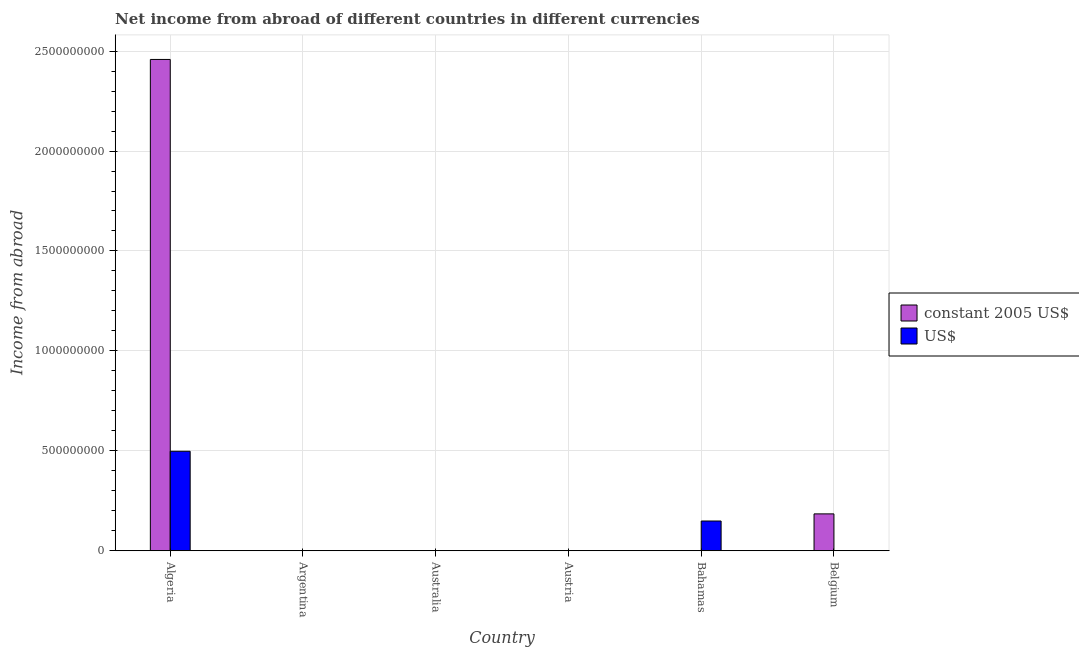How many different coloured bars are there?
Your answer should be compact. 2. Are the number of bars per tick equal to the number of legend labels?
Keep it short and to the point. No. How many bars are there on the 1st tick from the left?
Keep it short and to the point. 2. How many bars are there on the 1st tick from the right?
Give a very brief answer. 1. What is the label of the 3rd group of bars from the left?
Provide a short and direct response. Australia. What is the income from abroad in us$ in Austria?
Your answer should be very brief. 0. Across all countries, what is the maximum income from abroad in us$?
Your answer should be very brief. 4.98e+08. In which country was the income from abroad in us$ maximum?
Give a very brief answer. Algeria. What is the total income from abroad in constant 2005 us$ in the graph?
Your answer should be very brief. 2.64e+09. What is the difference between the income from abroad in constant 2005 us$ in Algeria and that in Belgium?
Ensure brevity in your answer.  2.27e+09. What is the difference between the income from abroad in constant 2005 us$ in Australia and the income from abroad in us$ in Argentina?
Your answer should be compact. 0. What is the average income from abroad in us$ per country?
Provide a succinct answer. 1.08e+08. What is the ratio of the income from abroad in constant 2005 us$ in Argentina to that in Belgium?
Your answer should be very brief. 1.8438339692605333e-11. What is the difference between the highest and the second highest income from abroad in constant 2005 us$?
Keep it short and to the point. 2.27e+09. What is the difference between the highest and the lowest income from abroad in constant 2005 us$?
Your response must be concise. 2.46e+09. In how many countries, is the income from abroad in us$ greater than the average income from abroad in us$ taken over all countries?
Offer a terse response. 2. How many bars are there?
Provide a succinct answer. 5. How many countries are there in the graph?
Provide a succinct answer. 6. Does the graph contain grids?
Your answer should be very brief. Yes. How many legend labels are there?
Your answer should be very brief. 2. What is the title of the graph?
Provide a short and direct response. Net income from abroad of different countries in different currencies. Does "Private funds" appear as one of the legend labels in the graph?
Make the answer very short. No. What is the label or title of the X-axis?
Give a very brief answer. Country. What is the label or title of the Y-axis?
Give a very brief answer. Income from abroad. What is the Income from abroad in constant 2005 US$ in Algeria?
Offer a terse response. 2.46e+09. What is the Income from abroad in US$ in Algeria?
Offer a very short reply. 4.98e+08. What is the Income from abroad in constant 2005 US$ in Argentina?
Offer a terse response. 0. What is the Income from abroad in US$ in Argentina?
Keep it short and to the point. 0. What is the Income from abroad in constant 2005 US$ in Australia?
Offer a very short reply. 0. What is the Income from abroad of constant 2005 US$ in Austria?
Keep it short and to the point. 0. What is the Income from abroad in US$ in Austria?
Your answer should be very brief. 0. What is the Income from abroad of US$ in Bahamas?
Keep it short and to the point. 1.49e+08. What is the Income from abroad of constant 2005 US$ in Belgium?
Ensure brevity in your answer.  1.85e+08. Across all countries, what is the maximum Income from abroad in constant 2005 US$?
Offer a terse response. 2.46e+09. Across all countries, what is the maximum Income from abroad of US$?
Give a very brief answer. 4.98e+08. Across all countries, what is the minimum Income from abroad of constant 2005 US$?
Give a very brief answer. 0. What is the total Income from abroad in constant 2005 US$ in the graph?
Your answer should be compact. 2.64e+09. What is the total Income from abroad in US$ in the graph?
Make the answer very short. 6.47e+08. What is the difference between the Income from abroad in constant 2005 US$ in Algeria and that in Argentina?
Ensure brevity in your answer.  2.46e+09. What is the difference between the Income from abroad in US$ in Algeria and that in Bahamas?
Provide a short and direct response. 3.49e+08. What is the difference between the Income from abroad of constant 2005 US$ in Algeria and that in Belgium?
Your answer should be very brief. 2.27e+09. What is the difference between the Income from abroad of constant 2005 US$ in Argentina and that in Belgium?
Your answer should be very brief. -1.85e+08. What is the difference between the Income from abroad of constant 2005 US$ in Algeria and the Income from abroad of US$ in Bahamas?
Provide a short and direct response. 2.31e+09. What is the difference between the Income from abroad of constant 2005 US$ in Argentina and the Income from abroad of US$ in Bahamas?
Provide a short and direct response. -1.49e+08. What is the average Income from abroad of constant 2005 US$ per country?
Offer a very short reply. 4.40e+08. What is the average Income from abroad in US$ per country?
Your response must be concise. 1.08e+08. What is the difference between the Income from abroad of constant 2005 US$ and Income from abroad of US$ in Algeria?
Provide a succinct answer. 1.96e+09. What is the ratio of the Income from abroad of constant 2005 US$ in Algeria to that in Argentina?
Your answer should be very brief. 7.22e+11. What is the ratio of the Income from abroad in US$ in Algeria to that in Bahamas?
Your response must be concise. 3.34. What is the ratio of the Income from abroad in constant 2005 US$ in Algeria to that in Belgium?
Ensure brevity in your answer.  13.32. What is the difference between the highest and the second highest Income from abroad in constant 2005 US$?
Make the answer very short. 2.27e+09. What is the difference between the highest and the lowest Income from abroad of constant 2005 US$?
Your response must be concise. 2.46e+09. What is the difference between the highest and the lowest Income from abroad of US$?
Provide a short and direct response. 4.98e+08. 